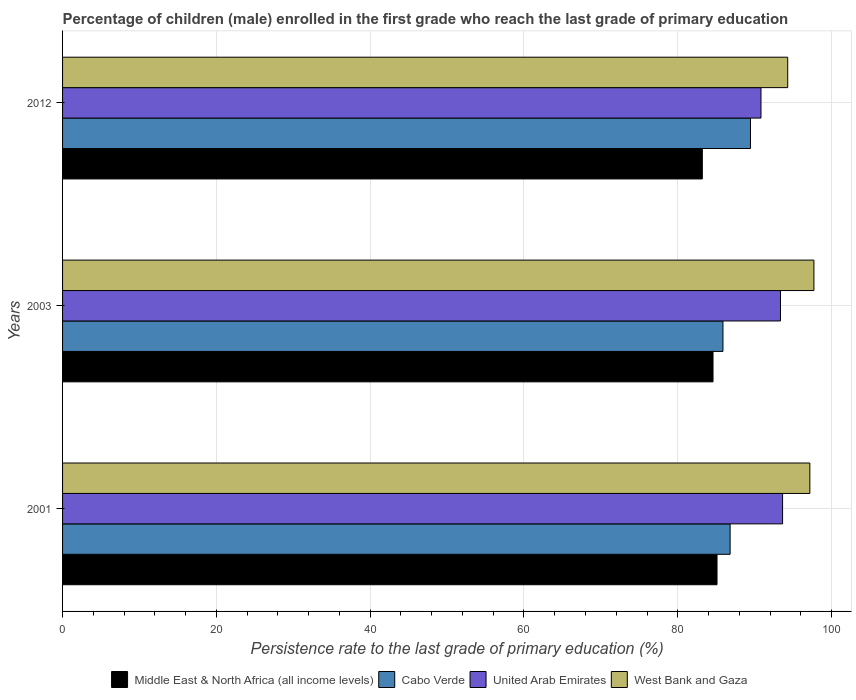How many groups of bars are there?
Make the answer very short. 3. How many bars are there on the 2nd tick from the top?
Provide a succinct answer. 4. How many bars are there on the 2nd tick from the bottom?
Offer a very short reply. 4. What is the label of the 1st group of bars from the top?
Your response must be concise. 2012. What is the persistence rate of children in Cabo Verde in 2012?
Ensure brevity in your answer.  89.45. Across all years, what is the maximum persistence rate of children in United Arab Emirates?
Provide a succinct answer. 93.62. Across all years, what is the minimum persistence rate of children in Middle East & North Africa (all income levels)?
Provide a short and direct response. 83.19. In which year was the persistence rate of children in West Bank and Gaza maximum?
Your response must be concise. 2003. In which year was the persistence rate of children in United Arab Emirates minimum?
Your answer should be compact. 2012. What is the total persistence rate of children in West Bank and Gaza in the graph?
Provide a short and direct response. 289.17. What is the difference between the persistence rate of children in Middle East & North Africa (all income levels) in 2001 and that in 2012?
Offer a terse response. 1.91. What is the difference between the persistence rate of children in Cabo Verde in 2003 and the persistence rate of children in United Arab Emirates in 2012?
Provide a succinct answer. -4.94. What is the average persistence rate of children in Cabo Verde per year?
Make the answer very short. 87.38. In the year 2012, what is the difference between the persistence rate of children in West Bank and Gaza and persistence rate of children in Middle East & North Africa (all income levels)?
Provide a succinct answer. 11.1. In how many years, is the persistence rate of children in Cabo Verde greater than 80 %?
Offer a very short reply. 3. What is the ratio of the persistence rate of children in Middle East & North Africa (all income levels) in 2001 to that in 2012?
Ensure brevity in your answer.  1.02. What is the difference between the highest and the second highest persistence rate of children in United Arab Emirates?
Ensure brevity in your answer.  0.27. What is the difference between the highest and the lowest persistence rate of children in West Bank and Gaza?
Your answer should be compact. 3.41. Is the sum of the persistence rate of children in United Arab Emirates in 2001 and 2003 greater than the maximum persistence rate of children in Cabo Verde across all years?
Provide a short and direct response. Yes. Is it the case that in every year, the sum of the persistence rate of children in West Bank and Gaza and persistence rate of children in Cabo Verde is greater than the sum of persistence rate of children in Middle East & North Africa (all income levels) and persistence rate of children in United Arab Emirates?
Your answer should be compact. Yes. What does the 4th bar from the top in 2003 represents?
Provide a short and direct response. Middle East & North Africa (all income levels). What does the 1st bar from the bottom in 2012 represents?
Provide a succinct answer. Middle East & North Africa (all income levels). How many years are there in the graph?
Ensure brevity in your answer.  3. What is the difference between two consecutive major ticks on the X-axis?
Provide a succinct answer. 20. How are the legend labels stacked?
Keep it short and to the point. Horizontal. What is the title of the graph?
Provide a succinct answer. Percentage of children (male) enrolled in the first grade who reach the last grade of primary education. Does "Greenland" appear as one of the legend labels in the graph?
Offer a terse response. No. What is the label or title of the X-axis?
Offer a very short reply. Persistence rate to the last grade of primary education (%). What is the Persistence rate to the last grade of primary education (%) in Middle East & North Africa (all income levels) in 2001?
Your answer should be very brief. 85.1. What is the Persistence rate to the last grade of primary education (%) of Cabo Verde in 2001?
Your response must be concise. 86.81. What is the Persistence rate to the last grade of primary education (%) of United Arab Emirates in 2001?
Your answer should be very brief. 93.62. What is the Persistence rate to the last grade of primary education (%) in West Bank and Gaza in 2001?
Offer a terse response. 97.17. What is the Persistence rate to the last grade of primary education (%) in Middle East & North Africa (all income levels) in 2003?
Offer a terse response. 84.58. What is the Persistence rate to the last grade of primary education (%) in Cabo Verde in 2003?
Make the answer very short. 85.87. What is the Persistence rate to the last grade of primary education (%) of United Arab Emirates in 2003?
Provide a short and direct response. 93.35. What is the Persistence rate to the last grade of primary education (%) of West Bank and Gaza in 2003?
Ensure brevity in your answer.  97.7. What is the Persistence rate to the last grade of primary education (%) in Middle East & North Africa (all income levels) in 2012?
Give a very brief answer. 83.19. What is the Persistence rate to the last grade of primary education (%) of Cabo Verde in 2012?
Your response must be concise. 89.45. What is the Persistence rate to the last grade of primary education (%) of United Arab Emirates in 2012?
Give a very brief answer. 90.82. What is the Persistence rate to the last grade of primary education (%) in West Bank and Gaza in 2012?
Offer a terse response. 94.29. Across all years, what is the maximum Persistence rate to the last grade of primary education (%) of Middle East & North Africa (all income levels)?
Make the answer very short. 85.1. Across all years, what is the maximum Persistence rate to the last grade of primary education (%) of Cabo Verde?
Provide a short and direct response. 89.45. Across all years, what is the maximum Persistence rate to the last grade of primary education (%) in United Arab Emirates?
Provide a short and direct response. 93.62. Across all years, what is the maximum Persistence rate to the last grade of primary education (%) of West Bank and Gaza?
Make the answer very short. 97.7. Across all years, what is the minimum Persistence rate to the last grade of primary education (%) in Middle East & North Africa (all income levels)?
Provide a succinct answer. 83.19. Across all years, what is the minimum Persistence rate to the last grade of primary education (%) in Cabo Verde?
Provide a succinct answer. 85.87. Across all years, what is the minimum Persistence rate to the last grade of primary education (%) in United Arab Emirates?
Your response must be concise. 90.82. Across all years, what is the minimum Persistence rate to the last grade of primary education (%) in West Bank and Gaza?
Provide a succinct answer. 94.29. What is the total Persistence rate to the last grade of primary education (%) in Middle East & North Africa (all income levels) in the graph?
Keep it short and to the point. 252.87. What is the total Persistence rate to the last grade of primary education (%) in Cabo Verde in the graph?
Your response must be concise. 262.13. What is the total Persistence rate to the last grade of primary education (%) of United Arab Emirates in the graph?
Keep it short and to the point. 277.79. What is the total Persistence rate to the last grade of primary education (%) in West Bank and Gaza in the graph?
Your answer should be very brief. 289.17. What is the difference between the Persistence rate to the last grade of primary education (%) in Middle East & North Africa (all income levels) in 2001 and that in 2003?
Your answer should be compact. 0.52. What is the difference between the Persistence rate to the last grade of primary education (%) of Cabo Verde in 2001 and that in 2003?
Provide a succinct answer. 0.93. What is the difference between the Persistence rate to the last grade of primary education (%) of United Arab Emirates in 2001 and that in 2003?
Your answer should be very brief. 0.27. What is the difference between the Persistence rate to the last grade of primary education (%) of West Bank and Gaza in 2001 and that in 2003?
Offer a terse response. -0.53. What is the difference between the Persistence rate to the last grade of primary education (%) of Middle East & North Africa (all income levels) in 2001 and that in 2012?
Offer a very short reply. 1.91. What is the difference between the Persistence rate to the last grade of primary education (%) in Cabo Verde in 2001 and that in 2012?
Provide a short and direct response. -2.65. What is the difference between the Persistence rate to the last grade of primary education (%) in United Arab Emirates in 2001 and that in 2012?
Provide a short and direct response. 2.81. What is the difference between the Persistence rate to the last grade of primary education (%) of West Bank and Gaza in 2001 and that in 2012?
Your answer should be very brief. 2.88. What is the difference between the Persistence rate to the last grade of primary education (%) of Middle East & North Africa (all income levels) in 2003 and that in 2012?
Your answer should be compact. 1.39. What is the difference between the Persistence rate to the last grade of primary education (%) in Cabo Verde in 2003 and that in 2012?
Give a very brief answer. -3.58. What is the difference between the Persistence rate to the last grade of primary education (%) of United Arab Emirates in 2003 and that in 2012?
Make the answer very short. 2.54. What is the difference between the Persistence rate to the last grade of primary education (%) of West Bank and Gaza in 2003 and that in 2012?
Offer a very short reply. 3.41. What is the difference between the Persistence rate to the last grade of primary education (%) in Middle East & North Africa (all income levels) in 2001 and the Persistence rate to the last grade of primary education (%) in Cabo Verde in 2003?
Make the answer very short. -0.77. What is the difference between the Persistence rate to the last grade of primary education (%) of Middle East & North Africa (all income levels) in 2001 and the Persistence rate to the last grade of primary education (%) of United Arab Emirates in 2003?
Your answer should be compact. -8.25. What is the difference between the Persistence rate to the last grade of primary education (%) of Middle East & North Africa (all income levels) in 2001 and the Persistence rate to the last grade of primary education (%) of West Bank and Gaza in 2003?
Provide a short and direct response. -12.6. What is the difference between the Persistence rate to the last grade of primary education (%) in Cabo Verde in 2001 and the Persistence rate to the last grade of primary education (%) in United Arab Emirates in 2003?
Provide a succinct answer. -6.55. What is the difference between the Persistence rate to the last grade of primary education (%) of Cabo Verde in 2001 and the Persistence rate to the last grade of primary education (%) of West Bank and Gaza in 2003?
Your answer should be compact. -10.9. What is the difference between the Persistence rate to the last grade of primary education (%) of United Arab Emirates in 2001 and the Persistence rate to the last grade of primary education (%) of West Bank and Gaza in 2003?
Make the answer very short. -4.08. What is the difference between the Persistence rate to the last grade of primary education (%) of Middle East & North Africa (all income levels) in 2001 and the Persistence rate to the last grade of primary education (%) of Cabo Verde in 2012?
Your response must be concise. -4.35. What is the difference between the Persistence rate to the last grade of primary education (%) in Middle East & North Africa (all income levels) in 2001 and the Persistence rate to the last grade of primary education (%) in United Arab Emirates in 2012?
Your answer should be very brief. -5.72. What is the difference between the Persistence rate to the last grade of primary education (%) of Middle East & North Africa (all income levels) in 2001 and the Persistence rate to the last grade of primary education (%) of West Bank and Gaza in 2012?
Offer a terse response. -9.19. What is the difference between the Persistence rate to the last grade of primary education (%) in Cabo Verde in 2001 and the Persistence rate to the last grade of primary education (%) in United Arab Emirates in 2012?
Make the answer very short. -4.01. What is the difference between the Persistence rate to the last grade of primary education (%) of Cabo Verde in 2001 and the Persistence rate to the last grade of primary education (%) of West Bank and Gaza in 2012?
Provide a short and direct response. -7.49. What is the difference between the Persistence rate to the last grade of primary education (%) in United Arab Emirates in 2001 and the Persistence rate to the last grade of primary education (%) in West Bank and Gaza in 2012?
Your answer should be compact. -0.67. What is the difference between the Persistence rate to the last grade of primary education (%) in Middle East & North Africa (all income levels) in 2003 and the Persistence rate to the last grade of primary education (%) in Cabo Verde in 2012?
Offer a terse response. -4.87. What is the difference between the Persistence rate to the last grade of primary education (%) in Middle East & North Africa (all income levels) in 2003 and the Persistence rate to the last grade of primary education (%) in United Arab Emirates in 2012?
Your answer should be compact. -6.24. What is the difference between the Persistence rate to the last grade of primary education (%) of Middle East & North Africa (all income levels) in 2003 and the Persistence rate to the last grade of primary education (%) of West Bank and Gaza in 2012?
Your answer should be very brief. -9.71. What is the difference between the Persistence rate to the last grade of primary education (%) of Cabo Verde in 2003 and the Persistence rate to the last grade of primary education (%) of United Arab Emirates in 2012?
Your answer should be compact. -4.94. What is the difference between the Persistence rate to the last grade of primary education (%) in Cabo Verde in 2003 and the Persistence rate to the last grade of primary education (%) in West Bank and Gaza in 2012?
Ensure brevity in your answer.  -8.42. What is the difference between the Persistence rate to the last grade of primary education (%) of United Arab Emirates in 2003 and the Persistence rate to the last grade of primary education (%) of West Bank and Gaza in 2012?
Your response must be concise. -0.94. What is the average Persistence rate to the last grade of primary education (%) of Middle East & North Africa (all income levels) per year?
Your response must be concise. 84.29. What is the average Persistence rate to the last grade of primary education (%) of Cabo Verde per year?
Your answer should be compact. 87.38. What is the average Persistence rate to the last grade of primary education (%) of United Arab Emirates per year?
Offer a terse response. 92.6. What is the average Persistence rate to the last grade of primary education (%) in West Bank and Gaza per year?
Provide a succinct answer. 96.39. In the year 2001, what is the difference between the Persistence rate to the last grade of primary education (%) in Middle East & North Africa (all income levels) and Persistence rate to the last grade of primary education (%) in Cabo Verde?
Give a very brief answer. -1.7. In the year 2001, what is the difference between the Persistence rate to the last grade of primary education (%) in Middle East & North Africa (all income levels) and Persistence rate to the last grade of primary education (%) in United Arab Emirates?
Your answer should be very brief. -8.52. In the year 2001, what is the difference between the Persistence rate to the last grade of primary education (%) in Middle East & North Africa (all income levels) and Persistence rate to the last grade of primary education (%) in West Bank and Gaza?
Your response must be concise. -12.07. In the year 2001, what is the difference between the Persistence rate to the last grade of primary education (%) of Cabo Verde and Persistence rate to the last grade of primary education (%) of United Arab Emirates?
Ensure brevity in your answer.  -6.82. In the year 2001, what is the difference between the Persistence rate to the last grade of primary education (%) in Cabo Verde and Persistence rate to the last grade of primary education (%) in West Bank and Gaza?
Ensure brevity in your answer.  -10.37. In the year 2001, what is the difference between the Persistence rate to the last grade of primary education (%) in United Arab Emirates and Persistence rate to the last grade of primary education (%) in West Bank and Gaza?
Keep it short and to the point. -3.55. In the year 2003, what is the difference between the Persistence rate to the last grade of primary education (%) of Middle East & North Africa (all income levels) and Persistence rate to the last grade of primary education (%) of Cabo Verde?
Provide a succinct answer. -1.29. In the year 2003, what is the difference between the Persistence rate to the last grade of primary education (%) of Middle East & North Africa (all income levels) and Persistence rate to the last grade of primary education (%) of United Arab Emirates?
Ensure brevity in your answer.  -8.77. In the year 2003, what is the difference between the Persistence rate to the last grade of primary education (%) of Middle East & North Africa (all income levels) and Persistence rate to the last grade of primary education (%) of West Bank and Gaza?
Give a very brief answer. -13.12. In the year 2003, what is the difference between the Persistence rate to the last grade of primary education (%) in Cabo Verde and Persistence rate to the last grade of primary education (%) in United Arab Emirates?
Your answer should be compact. -7.48. In the year 2003, what is the difference between the Persistence rate to the last grade of primary education (%) of Cabo Verde and Persistence rate to the last grade of primary education (%) of West Bank and Gaza?
Provide a succinct answer. -11.83. In the year 2003, what is the difference between the Persistence rate to the last grade of primary education (%) in United Arab Emirates and Persistence rate to the last grade of primary education (%) in West Bank and Gaza?
Your answer should be very brief. -4.35. In the year 2012, what is the difference between the Persistence rate to the last grade of primary education (%) of Middle East & North Africa (all income levels) and Persistence rate to the last grade of primary education (%) of Cabo Verde?
Make the answer very short. -6.26. In the year 2012, what is the difference between the Persistence rate to the last grade of primary education (%) in Middle East & North Africa (all income levels) and Persistence rate to the last grade of primary education (%) in United Arab Emirates?
Offer a terse response. -7.63. In the year 2012, what is the difference between the Persistence rate to the last grade of primary education (%) in Middle East & North Africa (all income levels) and Persistence rate to the last grade of primary education (%) in West Bank and Gaza?
Your answer should be compact. -11.1. In the year 2012, what is the difference between the Persistence rate to the last grade of primary education (%) of Cabo Verde and Persistence rate to the last grade of primary education (%) of United Arab Emirates?
Keep it short and to the point. -1.36. In the year 2012, what is the difference between the Persistence rate to the last grade of primary education (%) in Cabo Verde and Persistence rate to the last grade of primary education (%) in West Bank and Gaza?
Your answer should be compact. -4.84. In the year 2012, what is the difference between the Persistence rate to the last grade of primary education (%) of United Arab Emirates and Persistence rate to the last grade of primary education (%) of West Bank and Gaza?
Provide a short and direct response. -3.48. What is the ratio of the Persistence rate to the last grade of primary education (%) of Cabo Verde in 2001 to that in 2003?
Offer a very short reply. 1.01. What is the ratio of the Persistence rate to the last grade of primary education (%) in West Bank and Gaza in 2001 to that in 2003?
Make the answer very short. 0.99. What is the ratio of the Persistence rate to the last grade of primary education (%) in Cabo Verde in 2001 to that in 2012?
Your response must be concise. 0.97. What is the ratio of the Persistence rate to the last grade of primary education (%) of United Arab Emirates in 2001 to that in 2012?
Provide a succinct answer. 1.03. What is the ratio of the Persistence rate to the last grade of primary education (%) of West Bank and Gaza in 2001 to that in 2012?
Ensure brevity in your answer.  1.03. What is the ratio of the Persistence rate to the last grade of primary education (%) in Middle East & North Africa (all income levels) in 2003 to that in 2012?
Your answer should be compact. 1.02. What is the ratio of the Persistence rate to the last grade of primary education (%) of Cabo Verde in 2003 to that in 2012?
Your answer should be very brief. 0.96. What is the ratio of the Persistence rate to the last grade of primary education (%) in United Arab Emirates in 2003 to that in 2012?
Your answer should be compact. 1.03. What is the ratio of the Persistence rate to the last grade of primary education (%) in West Bank and Gaza in 2003 to that in 2012?
Your answer should be very brief. 1.04. What is the difference between the highest and the second highest Persistence rate to the last grade of primary education (%) in Middle East & North Africa (all income levels)?
Ensure brevity in your answer.  0.52. What is the difference between the highest and the second highest Persistence rate to the last grade of primary education (%) in Cabo Verde?
Make the answer very short. 2.65. What is the difference between the highest and the second highest Persistence rate to the last grade of primary education (%) of United Arab Emirates?
Your response must be concise. 0.27. What is the difference between the highest and the second highest Persistence rate to the last grade of primary education (%) of West Bank and Gaza?
Your response must be concise. 0.53. What is the difference between the highest and the lowest Persistence rate to the last grade of primary education (%) of Middle East & North Africa (all income levels)?
Provide a succinct answer. 1.91. What is the difference between the highest and the lowest Persistence rate to the last grade of primary education (%) in Cabo Verde?
Your response must be concise. 3.58. What is the difference between the highest and the lowest Persistence rate to the last grade of primary education (%) of United Arab Emirates?
Provide a succinct answer. 2.81. What is the difference between the highest and the lowest Persistence rate to the last grade of primary education (%) of West Bank and Gaza?
Keep it short and to the point. 3.41. 